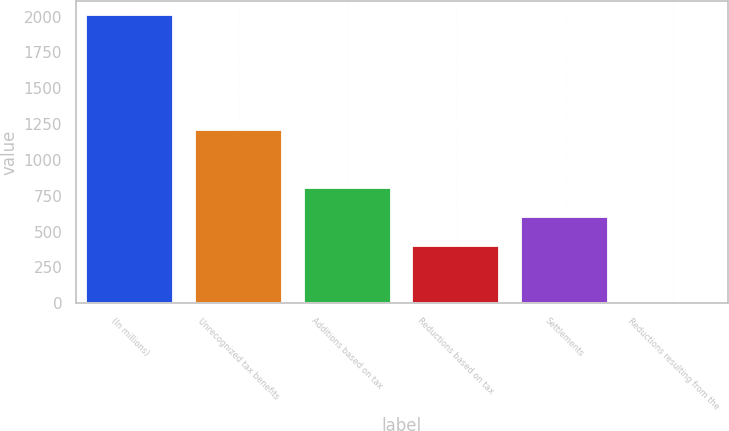Convert chart to OTSL. <chart><loc_0><loc_0><loc_500><loc_500><bar_chart><fcel>(In millions)<fcel>Unrecognized tax benefits<fcel>Additions based on tax<fcel>Reductions based on tax<fcel>Settlements<fcel>Reductions resulting from the<nl><fcel>2010<fcel>1206.08<fcel>804.12<fcel>402.16<fcel>603.14<fcel>0.2<nl></chart> 